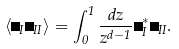<formula> <loc_0><loc_0><loc_500><loc_500>\left \langle \psi _ { I } \psi _ { I I } \right \rangle = \int _ { 0 } ^ { 1 } \frac { d z } { z ^ { d - 1 } } \psi ^ { * } _ { I } \psi _ { I I } .</formula> 